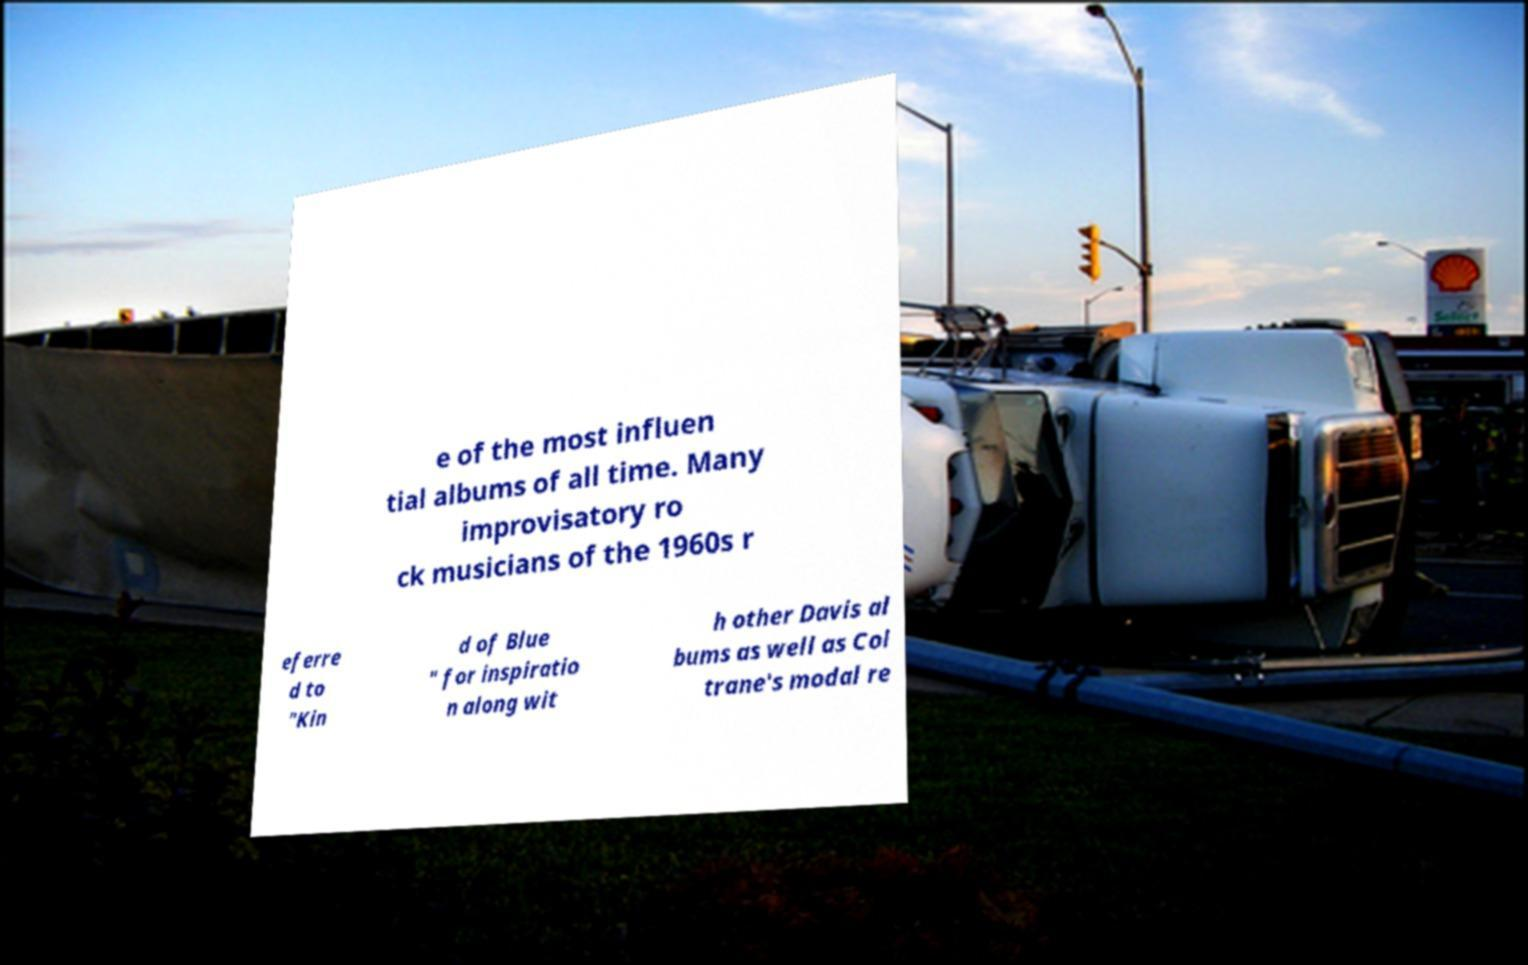Can you read and provide the text displayed in the image?This photo seems to have some interesting text. Can you extract and type it out for me? e of the most influen tial albums of all time. Many improvisatory ro ck musicians of the 1960s r eferre d to "Kin d of Blue " for inspiratio n along wit h other Davis al bums as well as Col trane's modal re 